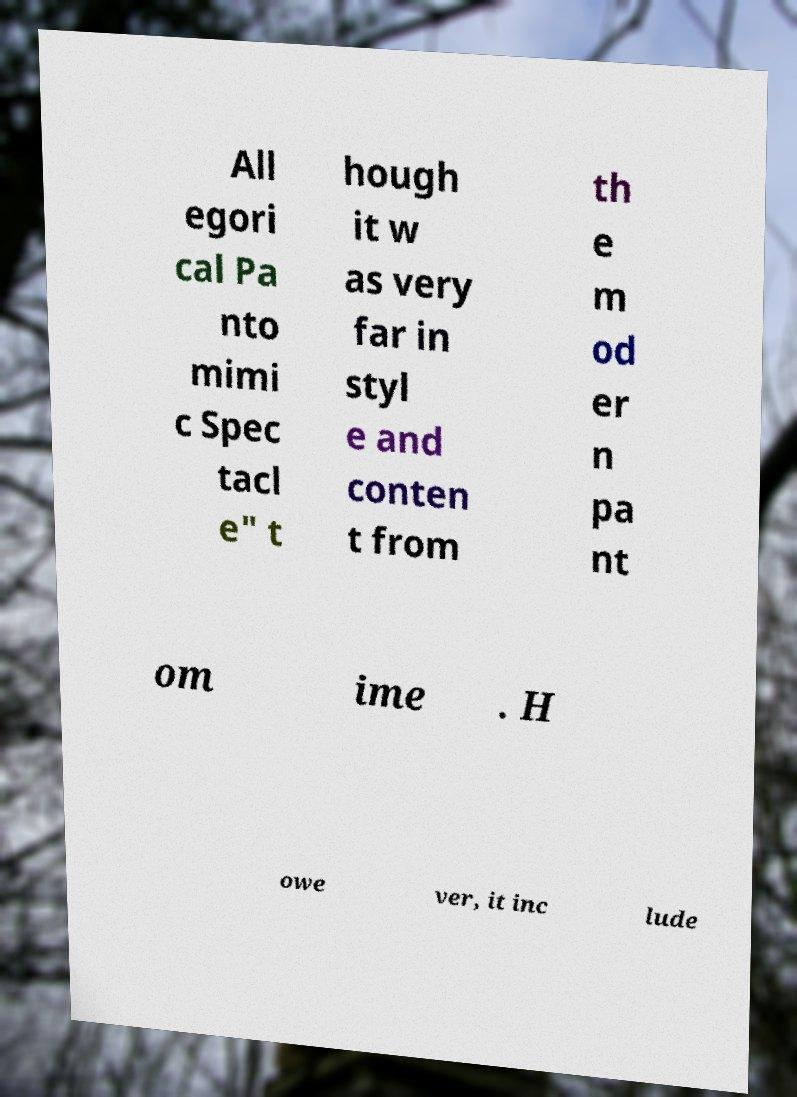Please read and relay the text visible in this image. What does it say? All egori cal Pa nto mimi c Spec tacl e" t hough it w as very far in styl e and conten t from th e m od er n pa nt om ime . H owe ver, it inc lude 